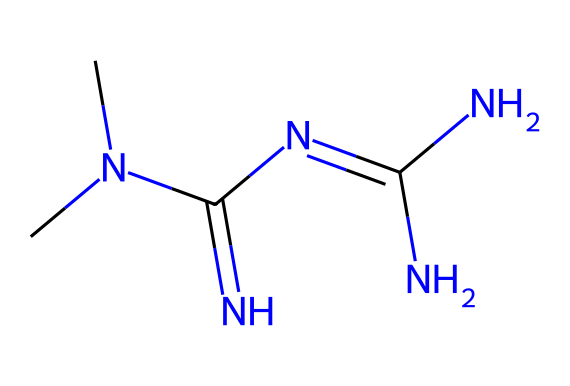What is the molecular formula of this compound? To find the molecular formula, we count the types and numbers of each atom represented in the chemical structure from the SMILES. This SMILES indicates 6 Carbon atoms (C), 14 Hydrogen atoms (H), 4 Nitrogen atoms (N), leading us to the formula C4H11N5.
Answer: C4H11N5 How many nitrogen atoms are present in the structure? By observing the SMILES, we identify the 'N' symbols, which indicate nitrogen atoms. Counting them shows there are 5 nitrogen atoms.
Answer: 5 What functional group is prominent in this compound? The presence of multiple nitrogen atoms in the structure indicates amines, and the specific arrangement suggests that it belongs to the class of guanidines. Thus, the functional group can be identified as guanidine.
Answer: guanidine Is this compound likely to be soluble in water? Given the presence of multiple nitrogen atoms and the polar nature of guanidines, this compound can be reasonably expected to have significant solubility in water due to its ability to interact with water molecules through hydrogen bonding.
Answer: yes What is the general biological activity of compounds with this structure? Compounds with a guanidine structure, such as this one, are often associated with activity related to glucose metabolism, making them relevant in the treatment of conditions like Type 2 diabetes.
Answer: antidiabetic 